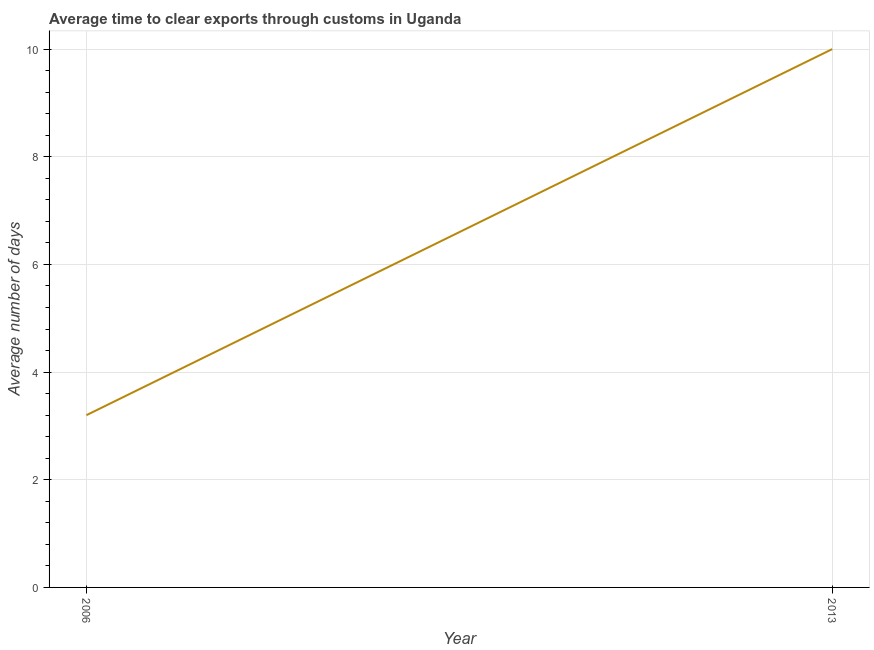What is the time to clear exports through customs in 2013?
Provide a succinct answer. 10. Across all years, what is the minimum time to clear exports through customs?
Give a very brief answer. 3.2. In which year was the time to clear exports through customs maximum?
Offer a terse response. 2013. What is the average time to clear exports through customs per year?
Keep it short and to the point. 6.6. What is the median time to clear exports through customs?
Your answer should be very brief. 6.6. What is the ratio of the time to clear exports through customs in 2006 to that in 2013?
Offer a very short reply. 0.32. How many years are there in the graph?
Offer a very short reply. 2. What is the difference between two consecutive major ticks on the Y-axis?
Your answer should be compact. 2. Does the graph contain grids?
Make the answer very short. Yes. What is the title of the graph?
Provide a short and direct response. Average time to clear exports through customs in Uganda. What is the label or title of the X-axis?
Offer a very short reply. Year. What is the label or title of the Y-axis?
Offer a terse response. Average number of days. What is the Average number of days in 2006?
Provide a succinct answer. 3.2. What is the Average number of days in 2013?
Offer a very short reply. 10. What is the difference between the Average number of days in 2006 and 2013?
Your answer should be very brief. -6.8. What is the ratio of the Average number of days in 2006 to that in 2013?
Keep it short and to the point. 0.32. 